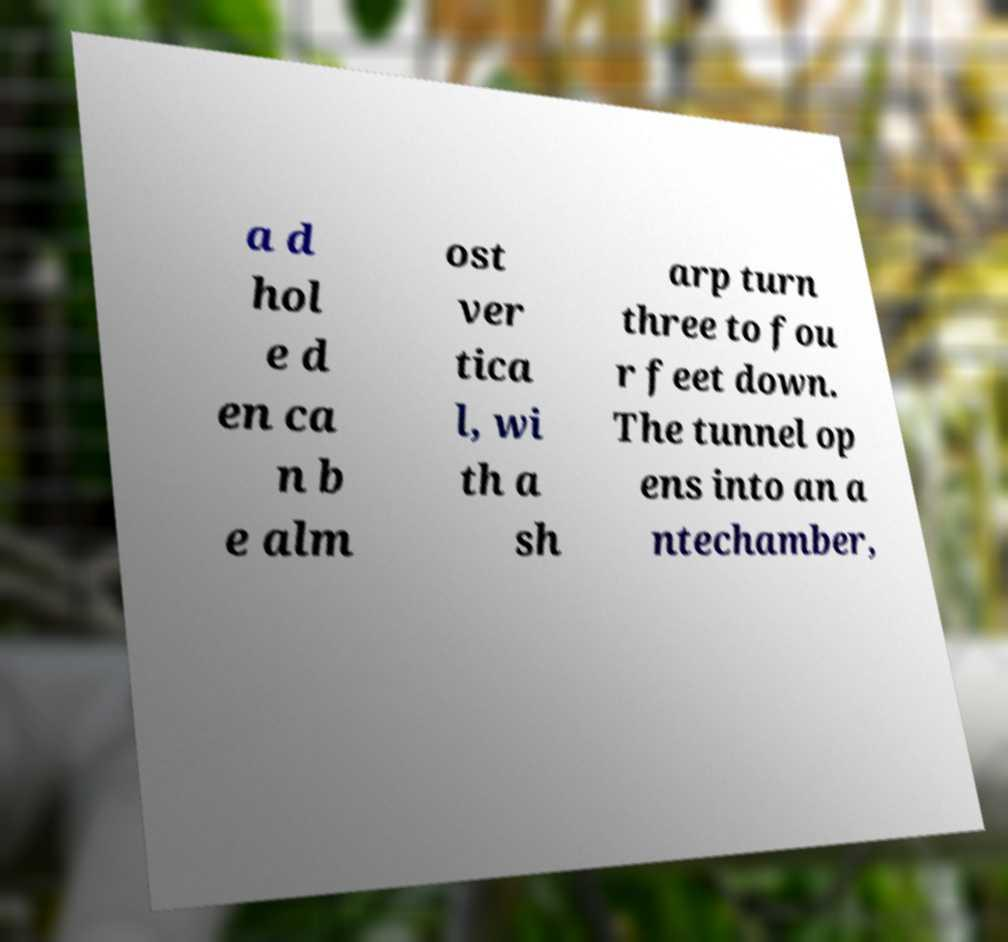Can you accurately transcribe the text from the provided image for me? a d hol e d en ca n b e alm ost ver tica l, wi th a sh arp turn three to fou r feet down. The tunnel op ens into an a ntechamber, 